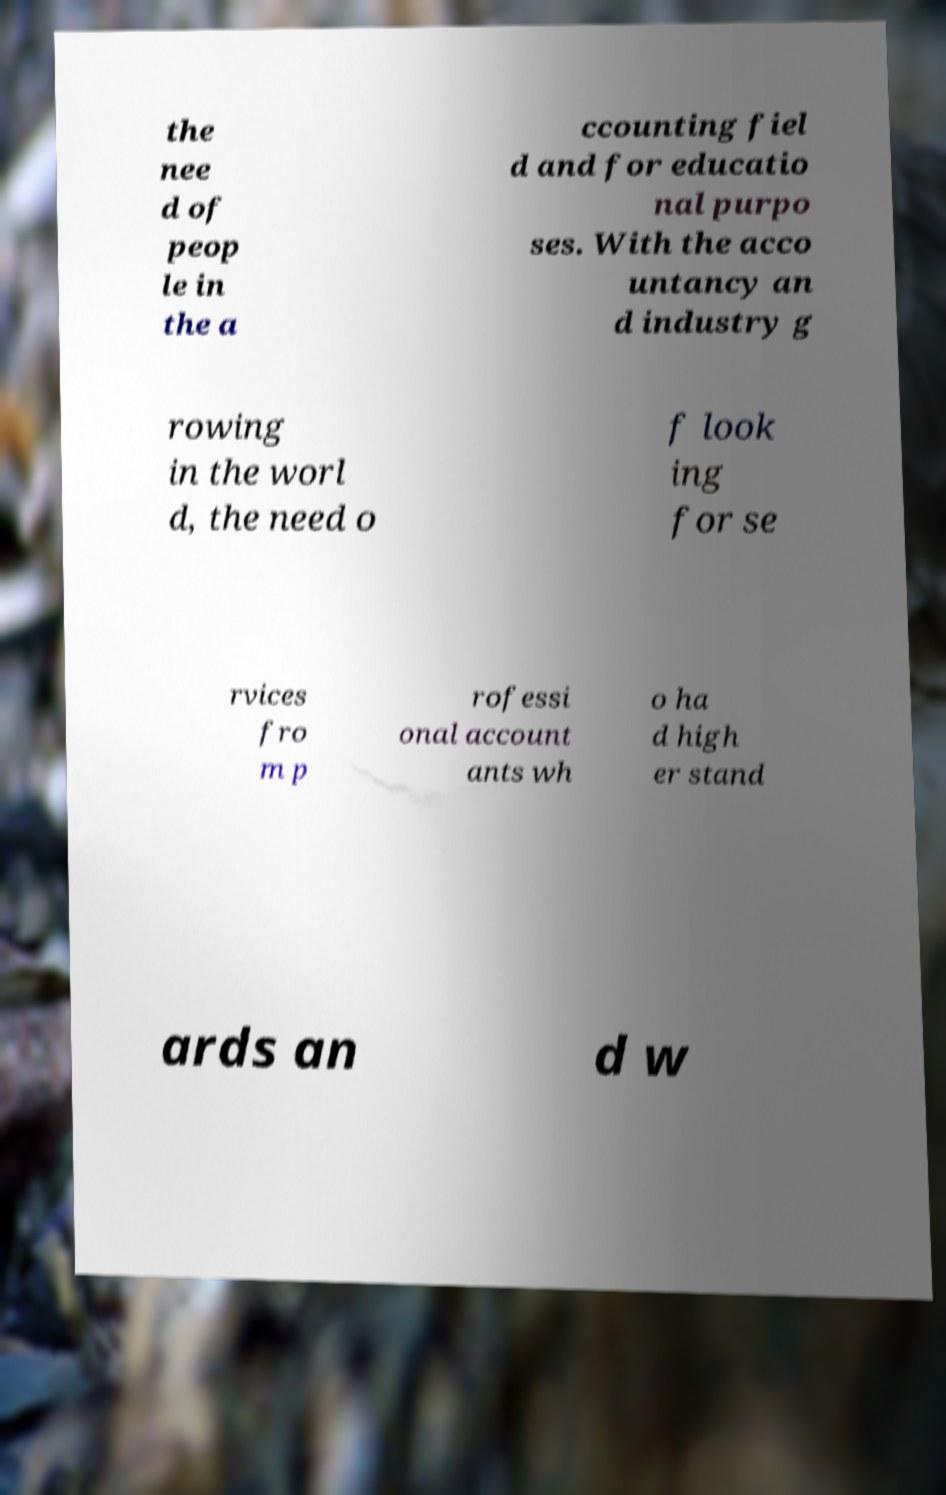Could you extract and type out the text from this image? the nee d of peop le in the a ccounting fiel d and for educatio nal purpo ses. With the acco untancy an d industry g rowing in the worl d, the need o f look ing for se rvices fro m p rofessi onal account ants wh o ha d high er stand ards an d w 